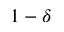Convert formula to latex. <formula><loc_0><loc_0><loc_500><loc_500>1 - \delta</formula> 